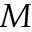Convert formula to latex. <formula><loc_0><loc_0><loc_500><loc_500>M</formula> 